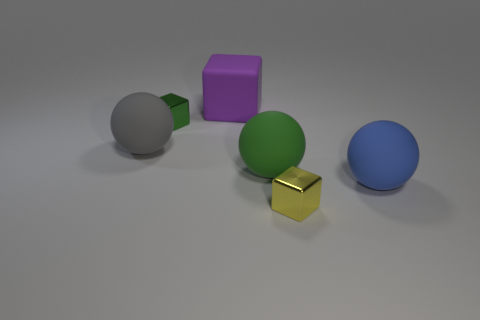Add 1 small blue cylinders. How many objects exist? 7 Add 5 small yellow metal cubes. How many small yellow metal cubes are left? 6 Add 4 red matte blocks. How many red matte blocks exist? 4 Subtract 0 brown blocks. How many objects are left? 6 Subtract all tiny metal blocks. Subtract all big gray matte objects. How many objects are left? 3 